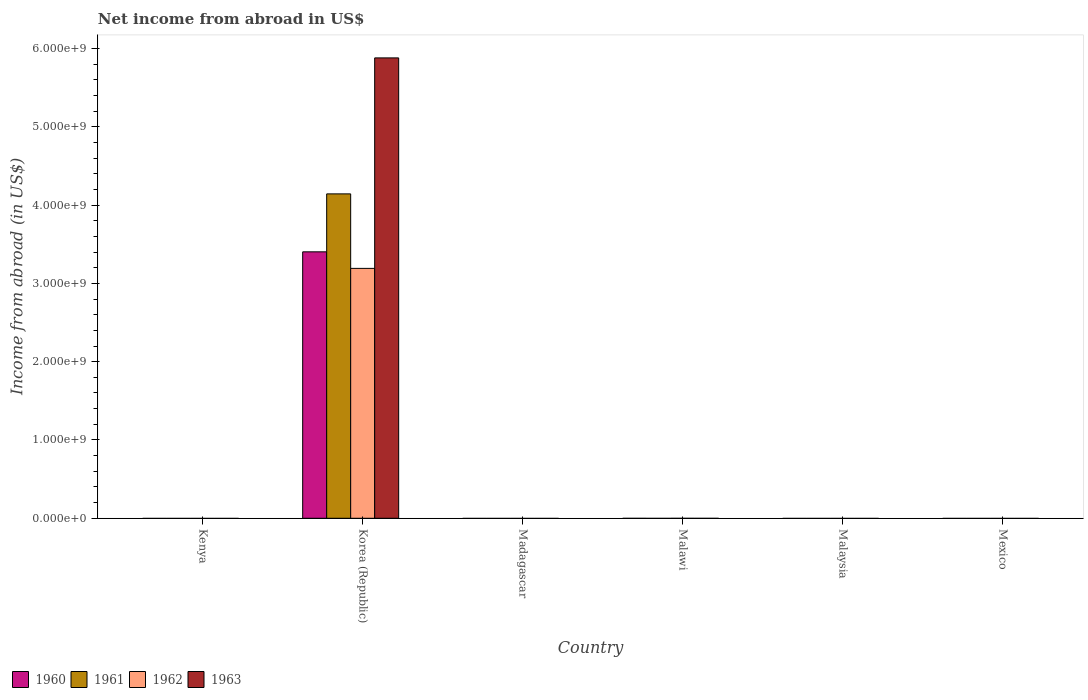How many different coloured bars are there?
Keep it short and to the point. 4. Are the number of bars per tick equal to the number of legend labels?
Provide a short and direct response. No. Are the number of bars on each tick of the X-axis equal?
Offer a terse response. No. How many bars are there on the 2nd tick from the right?
Offer a very short reply. 0. What is the label of the 1st group of bars from the left?
Your answer should be very brief. Kenya. Across all countries, what is the maximum net income from abroad in 1961?
Provide a succinct answer. 4.14e+09. Across all countries, what is the minimum net income from abroad in 1961?
Provide a short and direct response. 0. In which country was the net income from abroad in 1961 maximum?
Keep it short and to the point. Korea (Republic). What is the total net income from abroad in 1960 in the graph?
Ensure brevity in your answer.  3.40e+09. What is the average net income from abroad in 1962 per country?
Offer a very short reply. 5.32e+08. In how many countries, is the net income from abroad in 1962 greater than 3400000000 US$?
Ensure brevity in your answer.  0. What is the difference between the highest and the lowest net income from abroad in 1962?
Offer a very short reply. 3.19e+09. In how many countries, is the net income from abroad in 1961 greater than the average net income from abroad in 1961 taken over all countries?
Offer a very short reply. 1. How many bars are there?
Ensure brevity in your answer.  4. What is the difference between two consecutive major ticks on the Y-axis?
Make the answer very short. 1.00e+09. Are the values on the major ticks of Y-axis written in scientific E-notation?
Your response must be concise. Yes. Does the graph contain any zero values?
Keep it short and to the point. Yes. Does the graph contain grids?
Provide a short and direct response. No. Where does the legend appear in the graph?
Your answer should be compact. Bottom left. How many legend labels are there?
Your response must be concise. 4. What is the title of the graph?
Provide a short and direct response. Net income from abroad in US$. What is the label or title of the Y-axis?
Your response must be concise. Income from abroad (in US$). What is the Income from abroad (in US$) of 1962 in Kenya?
Offer a terse response. 0. What is the Income from abroad (in US$) in 1963 in Kenya?
Make the answer very short. 0. What is the Income from abroad (in US$) in 1960 in Korea (Republic)?
Make the answer very short. 3.40e+09. What is the Income from abroad (in US$) of 1961 in Korea (Republic)?
Give a very brief answer. 4.14e+09. What is the Income from abroad (in US$) in 1962 in Korea (Republic)?
Offer a very short reply. 3.19e+09. What is the Income from abroad (in US$) of 1963 in Korea (Republic)?
Provide a succinct answer. 5.88e+09. What is the Income from abroad (in US$) of 1960 in Madagascar?
Provide a succinct answer. 0. What is the Income from abroad (in US$) in 1961 in Madagascar?
Provide a short and direct response. 0. What is the Income from abroad (in US$) of 1962 in Madagascar?
Your response must be concise. 0. What is the Income from abroad (in US$) of 1960 in Malawi?
Offer a terse response. 0. What is the Income from abroad (in US$) in 1962 in Malawi?
Your response must be concise. 0. What is the Income from abroad (in US$) of 1963 in Malawi?
Ensure brevity in your answer.  0. What is the Income from abroad (in US$) of 1960 in Malaysia?
Give a very brief answer. 0. What is the Income from abroad (in US$) of 1962 in Malaysia?
Ensure brevity in your answer.  0. What is the Income from abroad (in US$) of 1963 in Malaysia?
Your answer should be compact. 0. What is the Income from abroad (in US$) in 1960 in Mexico?
Provide a succinct answer. 0. Across all countries, what is the maximum Income from abroad (in US$) of 1960?
Offer a terse response. 3.40e+09. Across all countries, what is the maximum Income from abroad (in US$) in 1961?
Make the answer very short. 4.14e+09. Across all countries, what is the maximum Income from abroad (in US$) of 1962?
Provide a succinct answer. 3.19e+09. Across all countries, what is the maximum Income from abroad (in US$) of 1963?
Provide a succinct answer. 5.88e+09. Across all countries, what is the minimum Income from abroad (in US$) of 1961?
Provide a succinct answer. 0. Across all countries, what is the minimum Income from abroad (in US$) in 1962?
Make the answer very short. 0. Across all countries, what is the minimum Income from abroad (in US$) of 1963?
Ensure brevity in your answer.  0. What is the total Income from abroad (in US$) in 1960 in the graph?
Keep it short and to the point. 3.40e+09. What is the total Income from abroad (in US$) of 1961 in the graph?
Provide a succinct answer. 4.14e+09. What is the total Income from abroad (in US$) in 1962 in the graph?
Provide a succinct answer. 3.19e+09. What is the total Income from abroad (in US$) in 1963 in the graph?
Offer a very short reply. 5.88e+09. What is the average Income from abroad (in US$) in 1960 per country?
Your response must be concise. 5.67e+08. What is the average Income from abroad (in US$) of 1961 per country?
Offer a terse response. 6.90e+08. What is the average Income from abroad (in US$) in 1962 per country?
Your response must be concise. 5.32e+08. What is the average Income from abroad (in US$) in 1963 per country?
Make the answer very short. 9.80e+08. What is the difference between the Income from abroad (in US$) of 1960 and Income from abroad (in US$) of 1961 in Korea (Republic)?
Ensure brevity in your answer.  -7.40e+08. What is the difference between the Income from abroad (in US$) of 1960 and Income from abroad (in US$) of 1962 in Korea (Republic)?
Make the answer very short. 2.11e+08. What is the difference between the Income from abroad (in US$) in 1960 and Income from abroad (in US$) in 1963 in Korea (Republic)?
Make the answer very short. -2.48e+09. What is the difference between the Income from abroad (in US$) in 1961 and Income from abroad (in US$) in 1962 in Korea (Republic)?
Make the answer very short. 9.52e+08. What is the difference between the Income from abroad (in US$) of 1961 and Income from abroad (in US$) of 1963 in Korea (Republic)?
Offer a very short reply. -1.74e+09. What is the difference between the Income from abroad (in US$) of 1962 and Income from abroad (in US$) of 1963 in Korea (Republic)?
Your answer should be compact. -2.69e+09. What is the difference between the highest and the lowest Income from abroad (in US$) in 1960?
Make the answer very short. 3.40e+09. What is the difference between the highest and the lowest Income from abroad (in US$) in 1961?
Ensure brevity in your answer.  4.14e+09. What is the difference between the highest and the lowest Income from abroad (in US$) of 1962?
Make the answer very short. 3.19e+09. What is the difference between the highest and the lowest Income from abroad (in US$) in 1963?
Your answer should be very brief. 5.88e+09. 